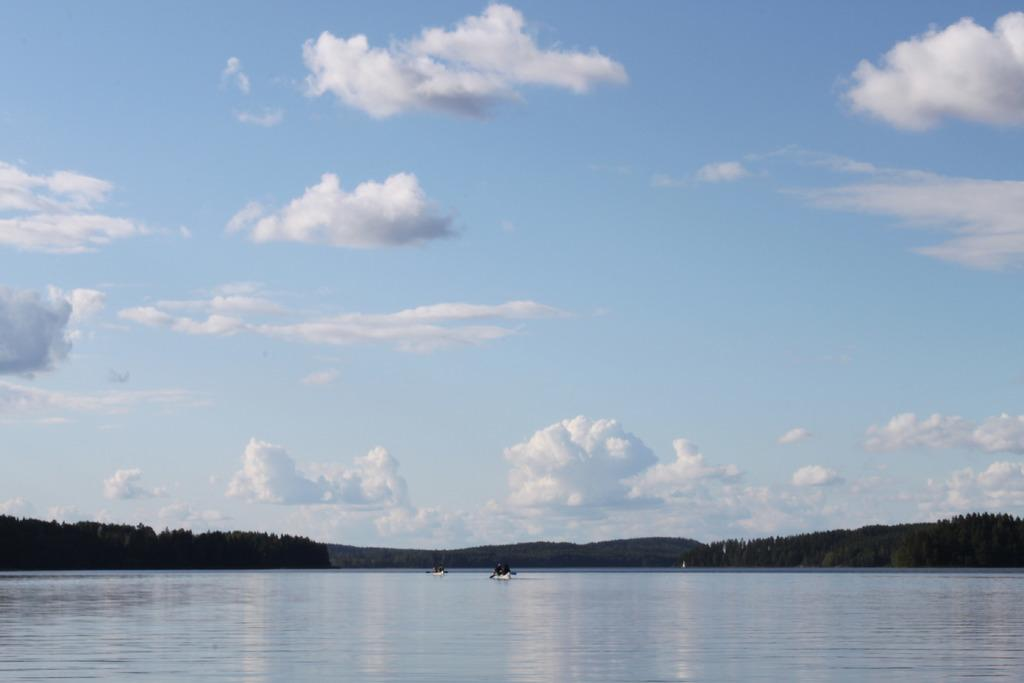What are the people in the image doing? The people in the image are sailing boats on the water. Where are the boats located? The boats are on the water. What can be seen in the background of the image? There are trees, hills, and a cloudy sky visible in the image. What type of cork can be seen floating on the water in the image? There is no cork visible in the image; it only shows people sailing boats on the water. Can you tell me how many wrens are perched on the trees in the image? There are no wrens present in the image; it only features trees, hills, and a cloudy sky in the background. 